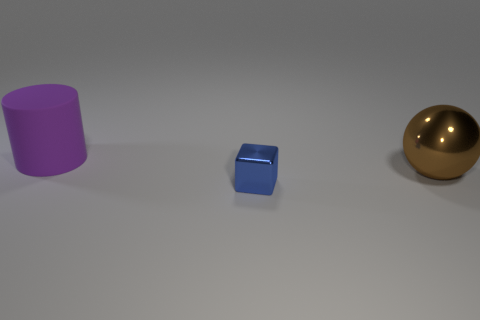What is the shape of the large thing on the right side of the big matte thing?
Provide a short and direct response. Sphere. How many large things are to the left of the brown shiny object and on the right side of the small shiny block?
Make the answer very short. 0. Is there a big brown ball that has the same material as the blue block?
Your response must be concise. Yes. How many blocks are red rubber things or blue objects?
Keep it short and to the point. 1. How big is the ball?
Offer a terse response. Large. There is a cylinder; how many large metal objects are on the left side of it?
Make the answer very short. 0. There is a metal thing on the right side of the metal object in front of the large brown metal thing; what is its size?
Your answer should be compact. Large. What is the shape of the object that is behind the metal thing that is to the right of the small blue thing?
Your answer should be compact. Cylinder. What is the size of the thing that is behind the cube and on the left side of the shiny ball?
Give a very brief answer. Large. How many other objects are there of the same size as the blue metallic object?
Make the answer very short. 0. 